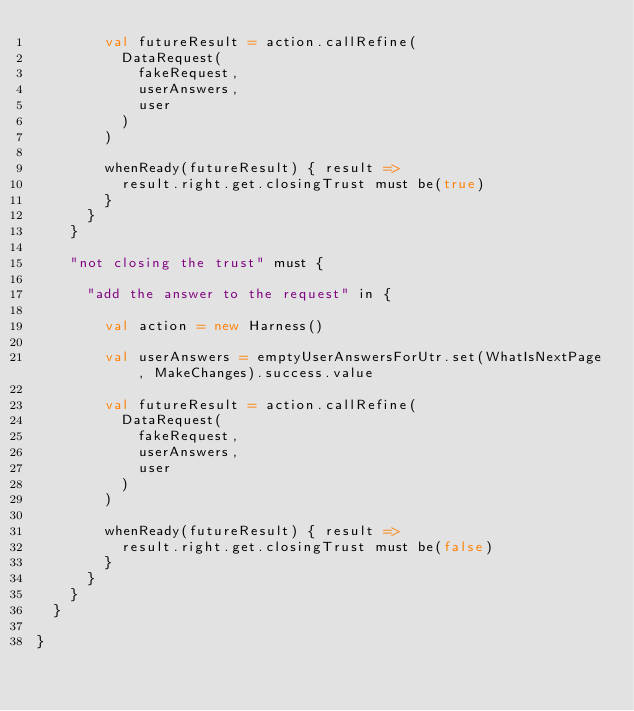Convert code to text. <code><loc_0><loc_0><loc_500><loc_500><_Scala_>        val futureResult = action.callRefine(
          DataRequest(
            fakeRequest,
            userAnswers,
            user
          )
        )

        whenReady(futureResult) { result =>
          result.right.get.closingTrust must be(true)
        }
      }
    }

    "not closing the trust" must {

      "add the answer to the request" in {

        val action = new Harness()

        val userAnswers = emptyUserAnswersForUtr.set(WhatIsNextPage, MakeChanges).success.value

        val futureResult = action.callRefine(
          DataRequest(
            fakeRequest,
            userAnswers,
            user
          )
        )

        whenReady(futureResult) { result =>
          result.right.get.closingTrust must be(false)
        }
      }
    }
  }

}
</code> 